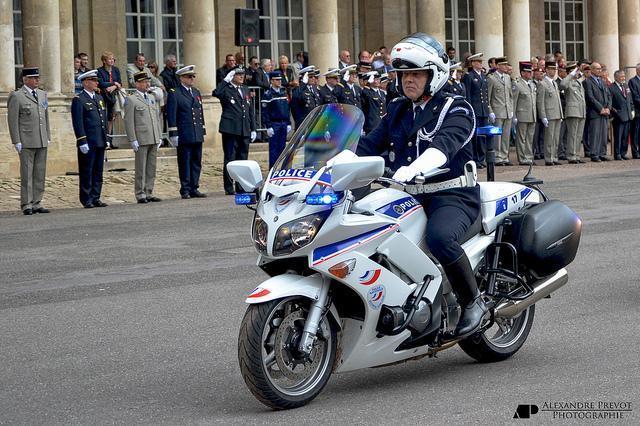How many people are there?
Give a very brief answer. 7. 